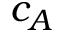<formula> <loc_0><loc_0><loc_500><loc_500>c _ { A }</formula> 